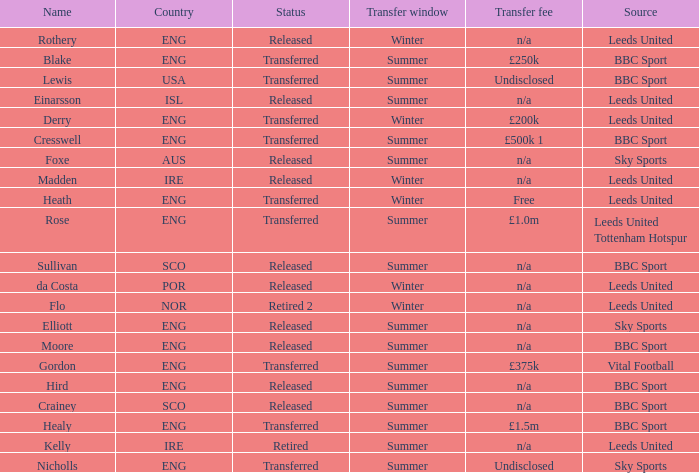What is the person's name that is from the country of SCO? Crainey, Sullivan. 